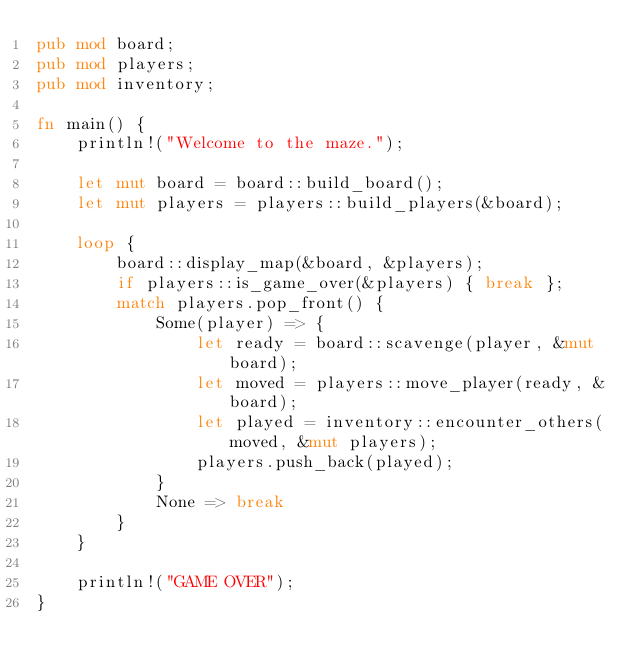<code> <loc_0><loc_0><loc_500><loc_500><_Rust_>pub mod board;
pub mod players;
pub mod inventory;

fn main() {
    println!("Welcome to the maze.");

    let mut board = board::build_board();
    let mut players = players::build_players(&board);

    loop {
        board::display_map(&board, &players);
        if players::is_game_over(&players) { break };
        match players.pop_front() {
            Some(player) => {
                let ready = board::scavenge(player, &mut board);
                let moved = players::move_player(ready, &board);
                let played = inventory::encounter_others(moved, &mut players);
                players.push_back(played);
            }
            None => break
        }
    }

    println!("GAME OVER");
}
</code> 